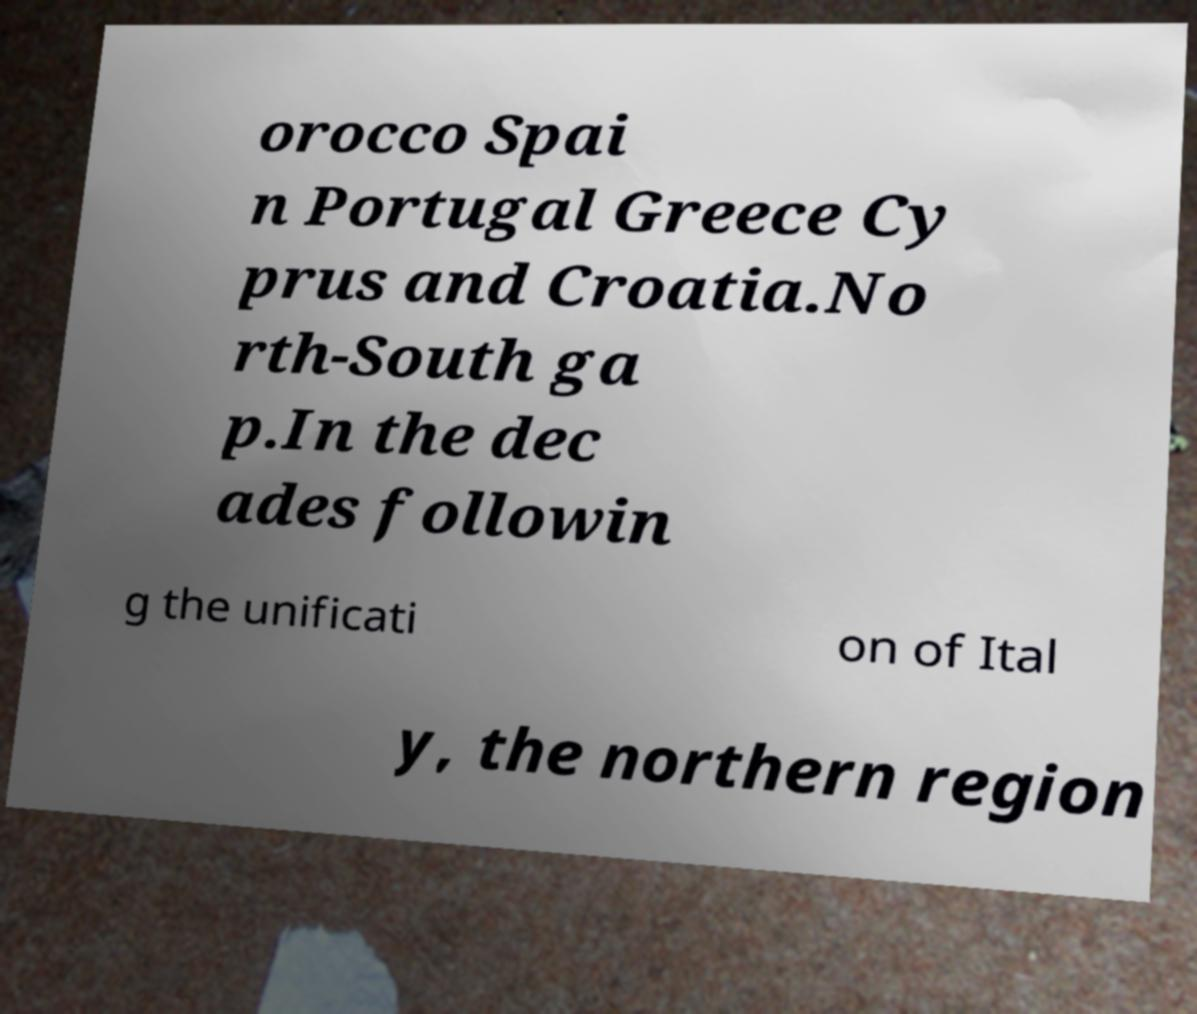Can you accurately transcribe the text from the provided image for me? orocco Spai n Portugal Greece Cy prus and Croatia.No rth-South ga p.In the dec ades followin g the unificati on of Ital y, the northern region 